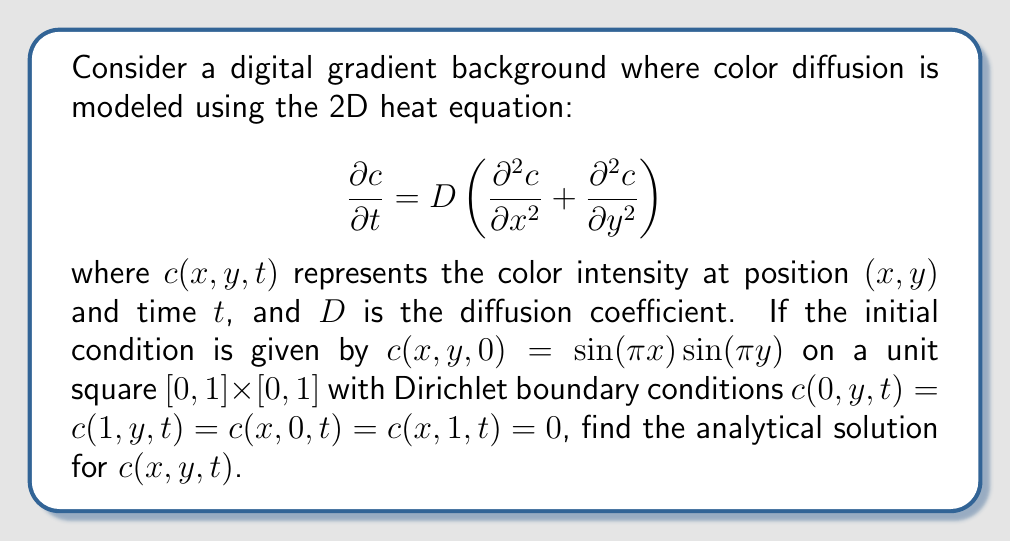Solve this math problem. To solve this problem, we'll use the method of separation of variables:

1) Assume the solution has the form: $c(x,y,t) = X(x)Y(y)T(t)$

2) Substituting into the heat equation:
   $$X'Y'T = D(X''YT + XY''T)$$

3) Dividing by $XYT$:
   $$\frac{T'}{T} = D\left(\frac{X''}{X} + \frac{Y''}{Y}\right) = -\lambda$$

   where $\lambda$ is a constant.

4) This gives us three ODEs:
   $$T' = -\lambda DT$$
   $$X'' + \mu^2 X = 0$$
   $$Y'' + \nu^2 Y = 0$$
   where $\lambda = \mu^2 + \nu^2$

5) Solving these ODEs with the given boundary conditions:
   $$T(t) = e^{-\lambda Dt}$$
   $$X(x) = \sin(n\pi x)$$
   $$Y(y) = \sin(m\pi y)$$
   where $n,m$ are positive integers.

6) The general solution is:
   $$c(x,y,t) = \sum_{n=1}^\infty \sum_{m=1}^\infty A_{nm} \sin(n\pi x)\sin(m\pi y)e^{-(n^2+m^2)\pi^2Dt}$$

7) Using the initial condition to find $A_{nm}$:
   $$c(x,y,0) = \sin(\pi x)\sin(\pi y) = \sum_{n=1}^\infty \sum_{m=1}^\infty A_{nm} \sin(n\pi x)\sin(m\pi y)$$

8) This implies $A_{11} = 1$ and $A_{nm} = 0$ for all other $n,m$.

Therefore, the analytical solution is:
$$c(x,y,t) = \sin(\pi x)\sin(\pi y)e^{-2\pi^2Dt}$$
Answer: $c(x,y,t) = \sin(\pi x)\sin(\pi y)e^{-2\pi^2Dt}$ 